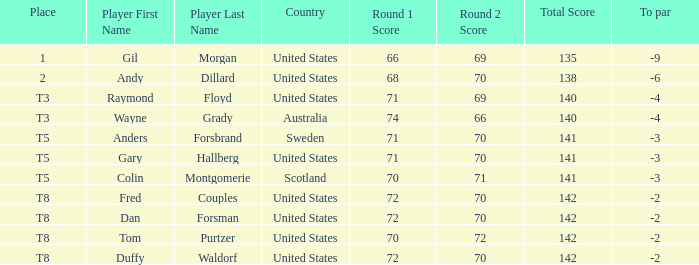With a score of 70-71=141, what is the to par for the player? -3.0. 